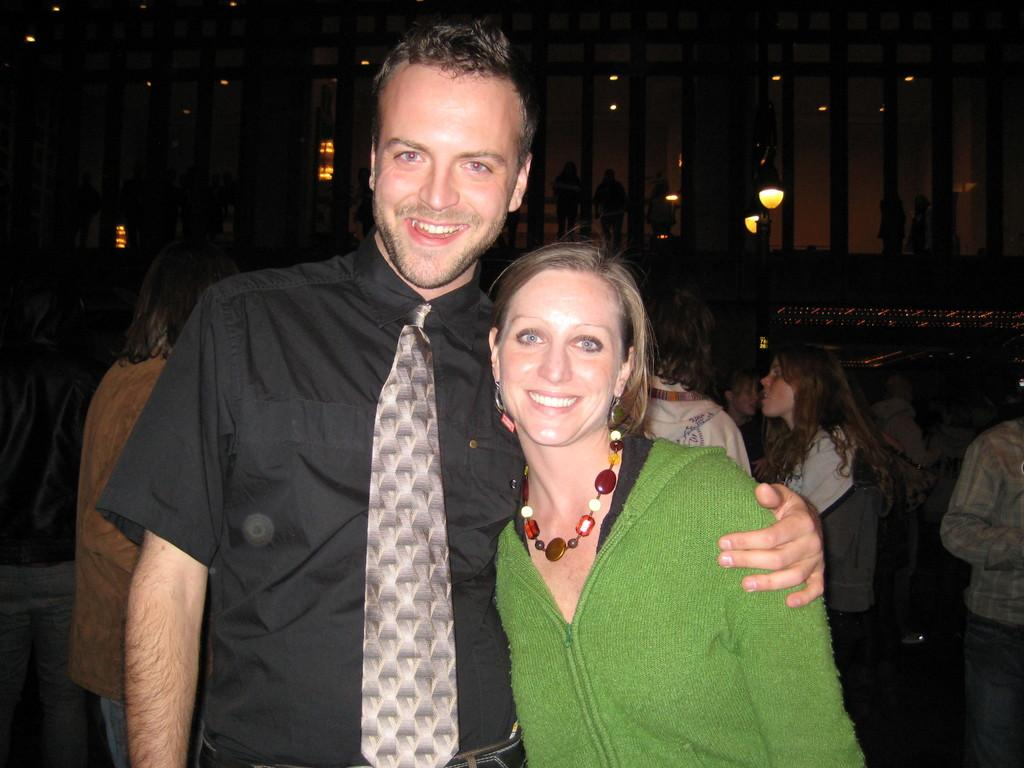What can be seen in the foreground of the image? There are persons standing in the front of the image. What are the expressions of the persons in the front? The persons in the front are smiling. What is visible in the background of the image? There is a group of persons, lights hanging, and a wooden fence in the background. What type of skate is being used by the persons in the image? There is no skate present in the image; the persons are standing on the ground. What type of approval is being given by the persons in the image? There is no indication of approval or disapproval in the image; the persons are simply standing and smiling. 